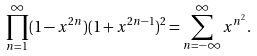<formula> <loc_0><loc_0><loc_500><loc_500>\prod _ { n = 1 } ^ { \infty } ( 1 - x ^ { 2 n } ) ( 1 + x ^ { 2 n - 1 } ) ^ { 2 } = \sum _ { n = - \infty } ^ { \infty } x ^ { n ^ { 2 } } .</formula> 